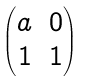Convert formula to latex. <formula><loc_0><loc_0><loc_500><loc_500>\begin{pmatrix} a & 0 \\ 1 & 1 \end{pmatrix}</formula> 